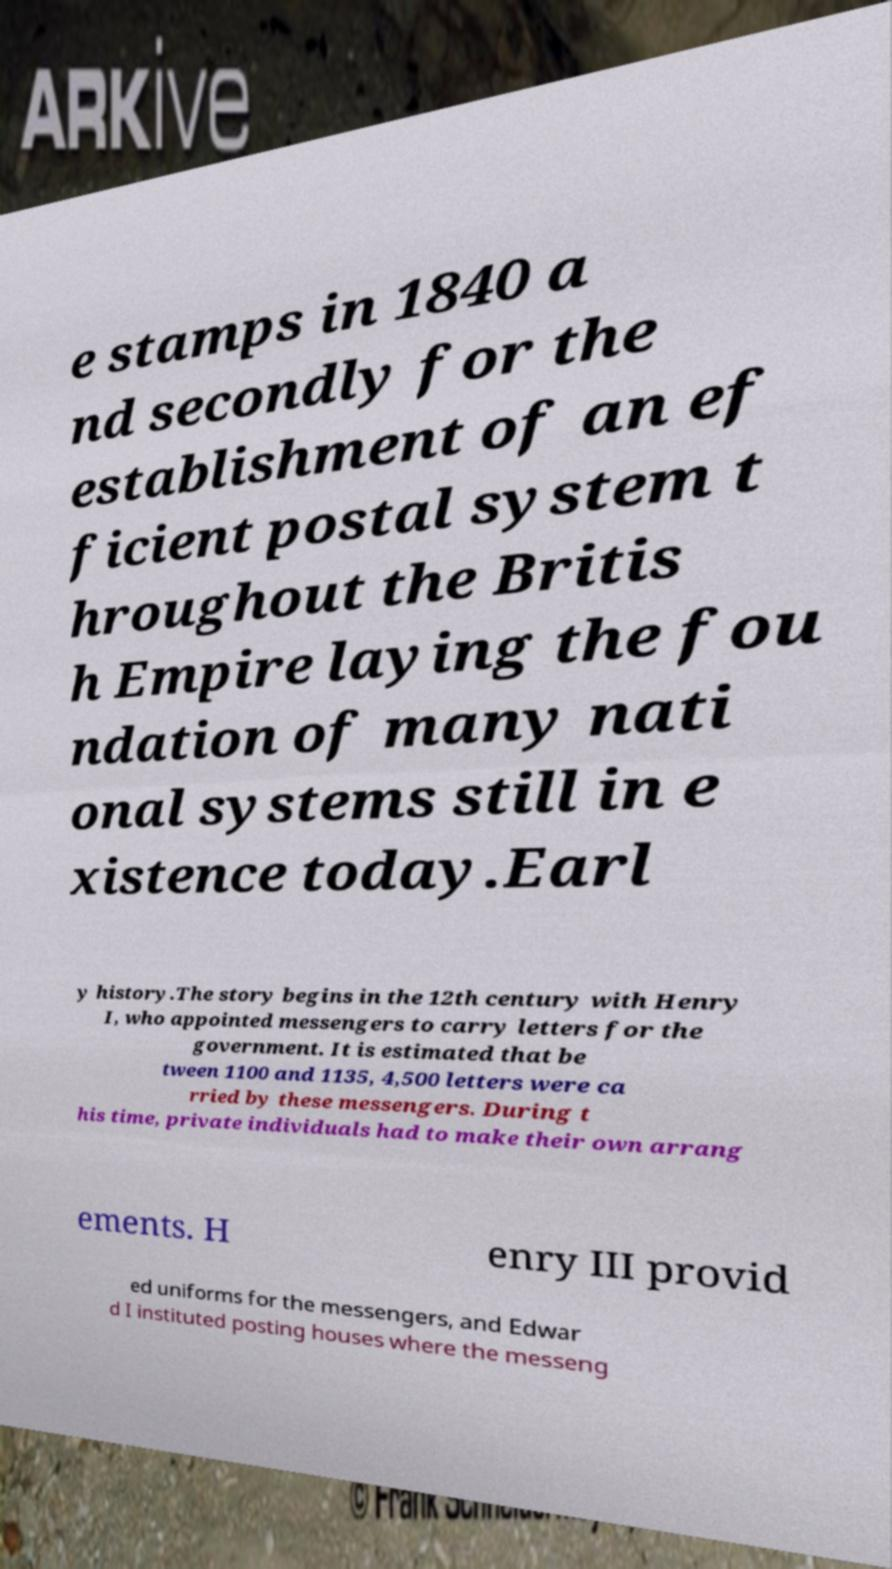I need the written content from this picture converted into text. Can you do that? e stamps in 1840 a nd secondly for the establishment of an ef ficient postal system t hroughout the Britis h Empire laying the fou ndation of many nati onal systems still in e xistence today.Earl y history.The story begins in the 12th century with Henry I, who appointed messengers to carry letters for the government. It is estimated that be tween 1100 and 1135, 4,500 letters were ca rried by these messengers. During t his time, private individuals had to make their own arrang ements. H enry III provid ed uniforms for the messengers, and Edwar d I instituted posting houses where the messeng 